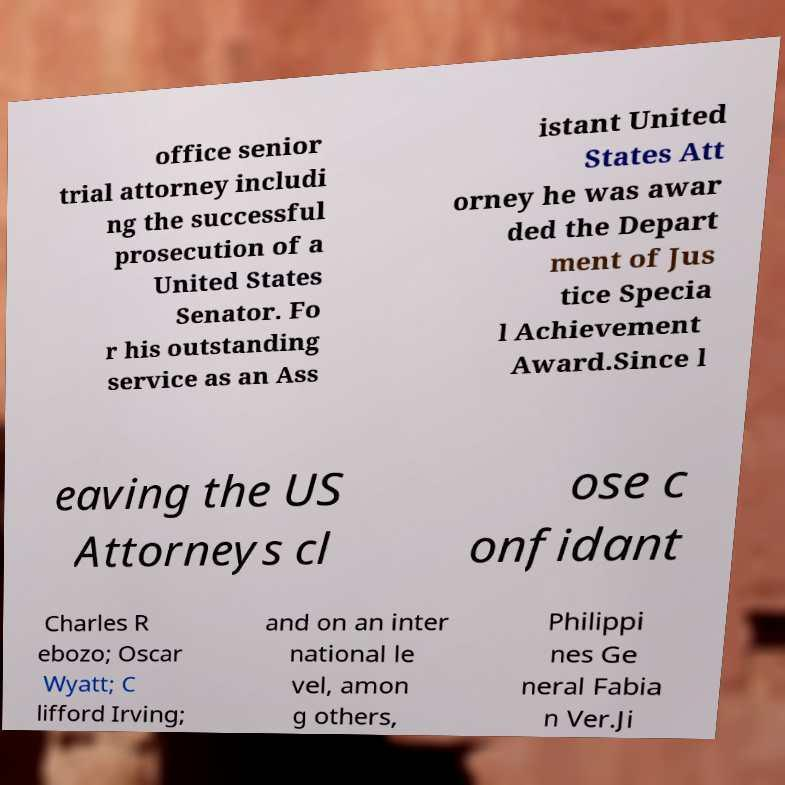Please read and relay the text visible in this image. What does it say? office senior trial attorney includi ng the successful prosecution of a United States Senator. Fo r his outstanding service as an Ass istant United States Att orney he was awar ded the Depart ment of Jus tice Specia l Achievement Award.Since l eaving the US Attorneys cl ose c onfidant Charles R ebozo; Oscar Wyatt; C lifford Irving; and on an inter national le vel, amon g others, Philippi nes Ge neral Fabia n Ver.Ji 